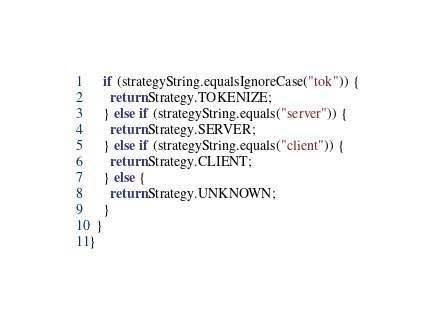Convert code to text. <code><loc_0><loc_0><loc_500><loc_500><_Java_>    if (strategyString.equalsIgnoreCase("tok")) {
      return Strategy.TOKENIZE;
    } else if (strategyString.equals("server")) {
      return Strategy.SERVER;
    } else if (strategyString.equals("client")) {
      return Strategy.CLIENT;
    } else {
      return Strategy.UNKNOWN;
    }
  }
}
</code> 